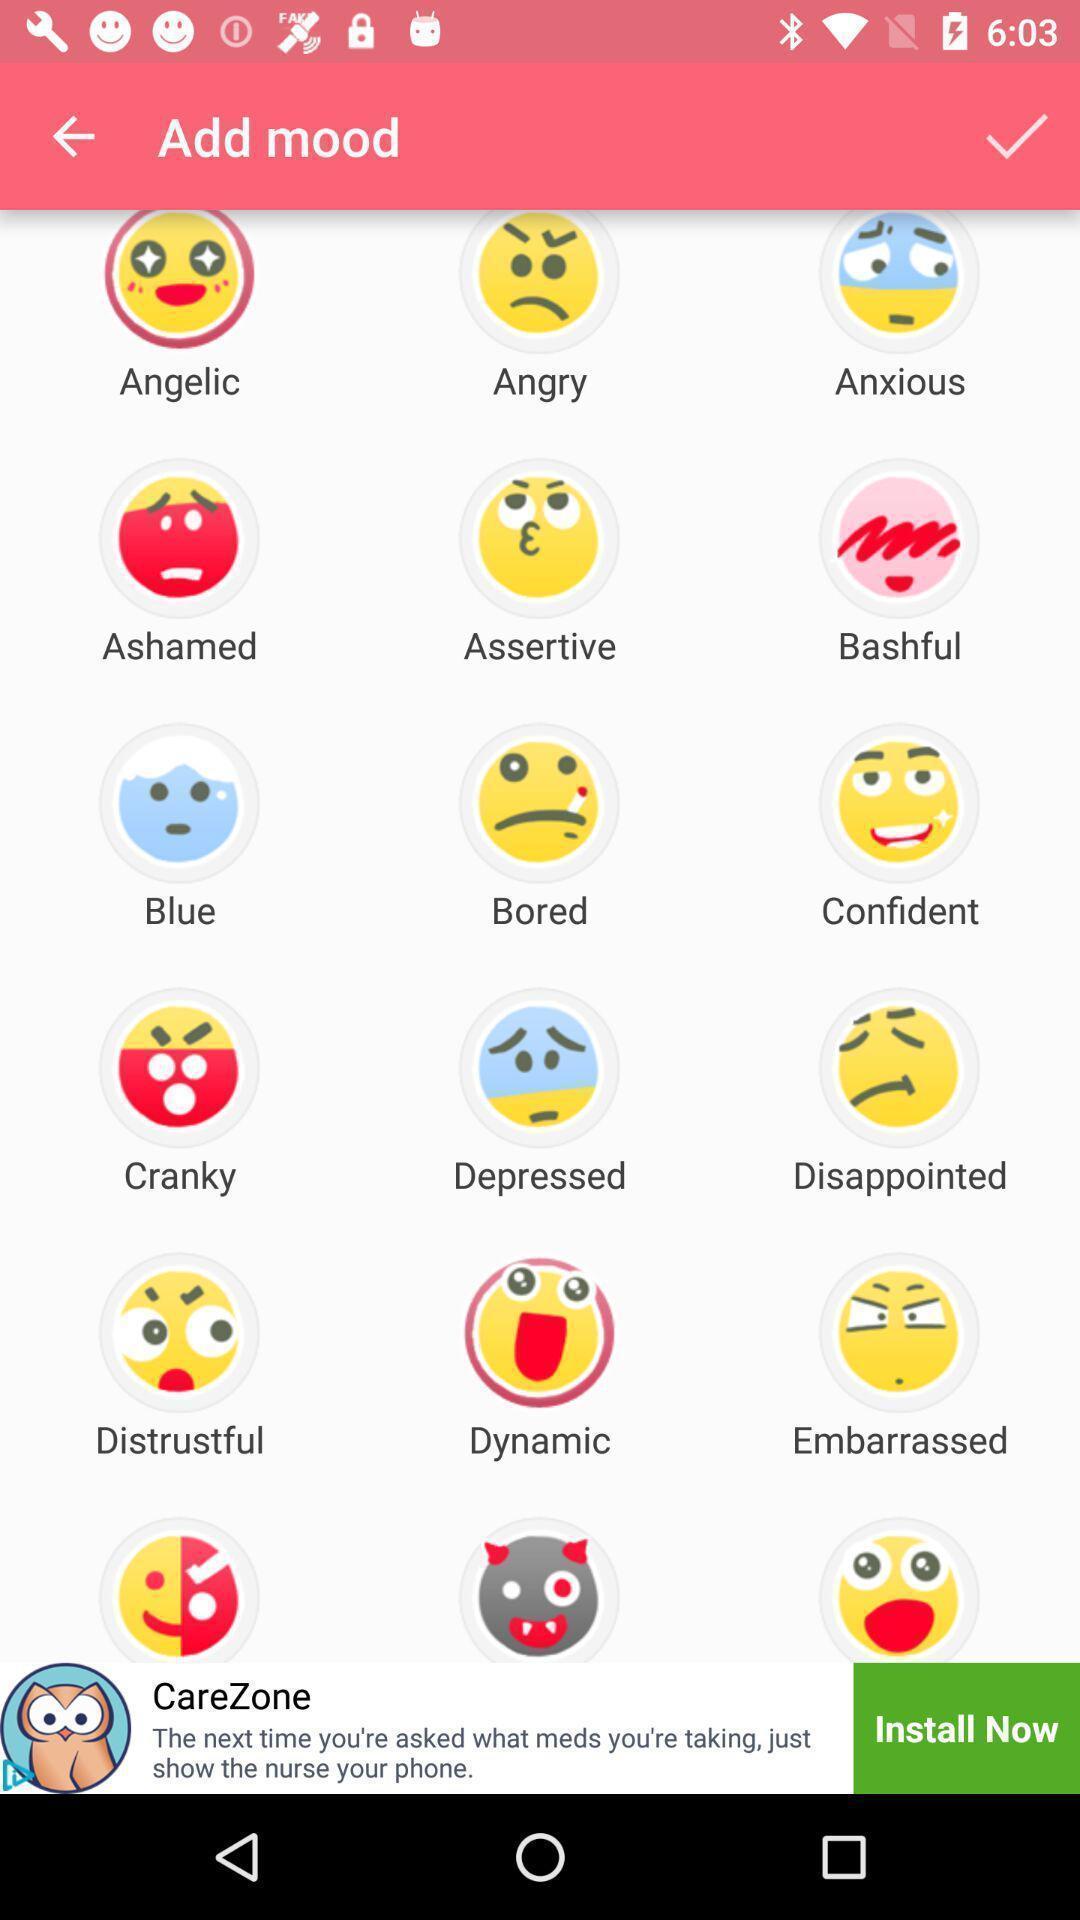Give me a summary of this screen capture. Social app showing list of mood. 